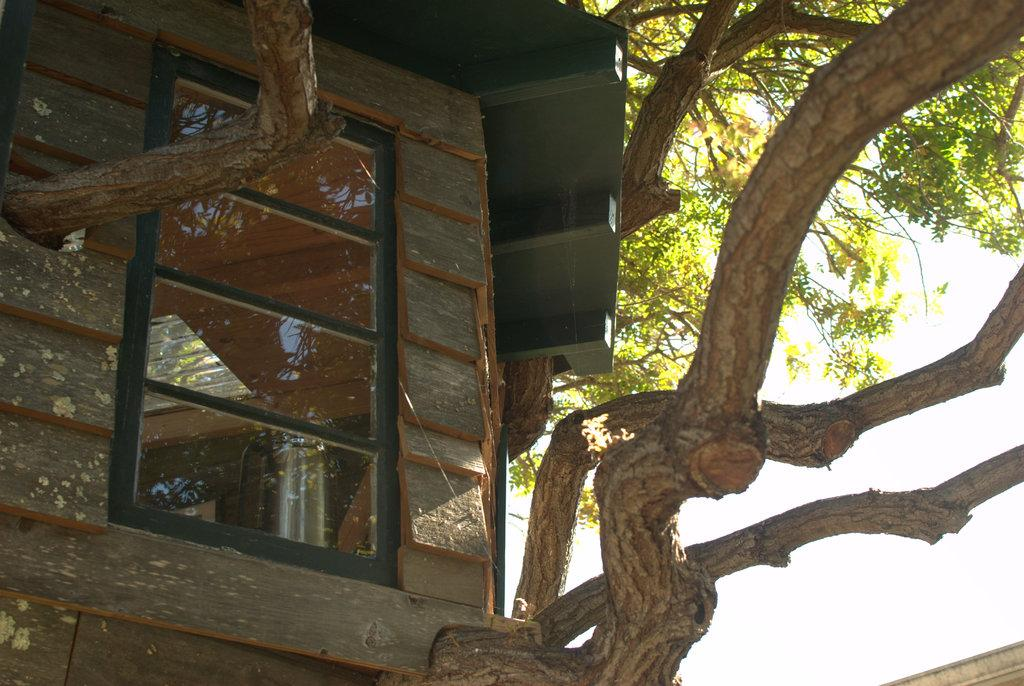What structure is located on the left side of the image? There is a building with windows on the left side of the image. What type of vegetation can be seen in the background of the image? There is a tree in the background of the image. What is visible in the background of the image besides the tree? The sky is visible in the background of the image. What type of caption is written on the building in the image? There is no caption written on the building in the image. Can you tell me the color of the minister's hat in the image? There is no minister or hat present in the image. 